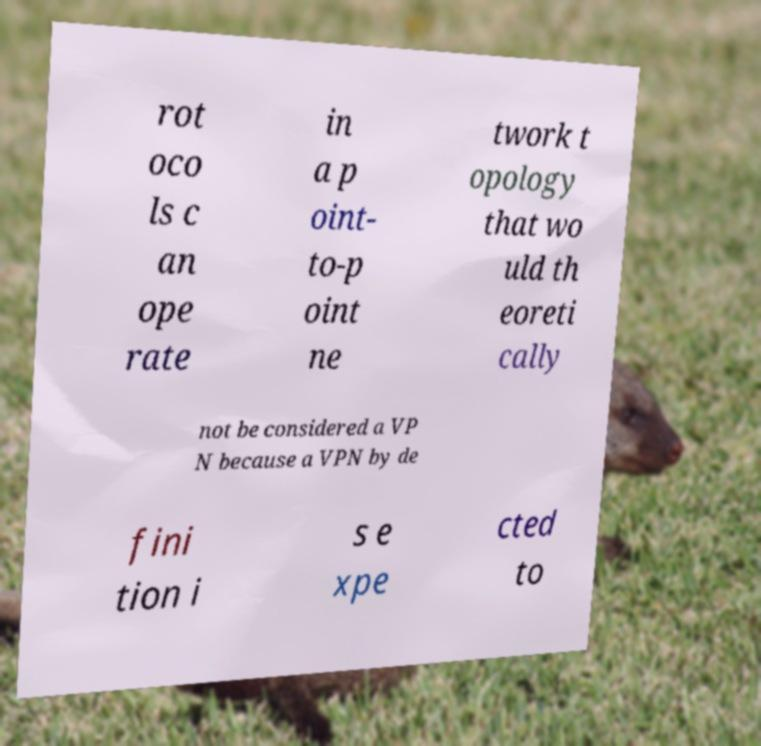There's text embedded in this image that I need extracted. Can you transcribe it verbatim? rot oco ls c an ope rate in a p oint- to-p oint ne twork t opology that wo uld th eoreti cally not be considered a VP N because a VPN by de fini tion i s e xpe cted to 